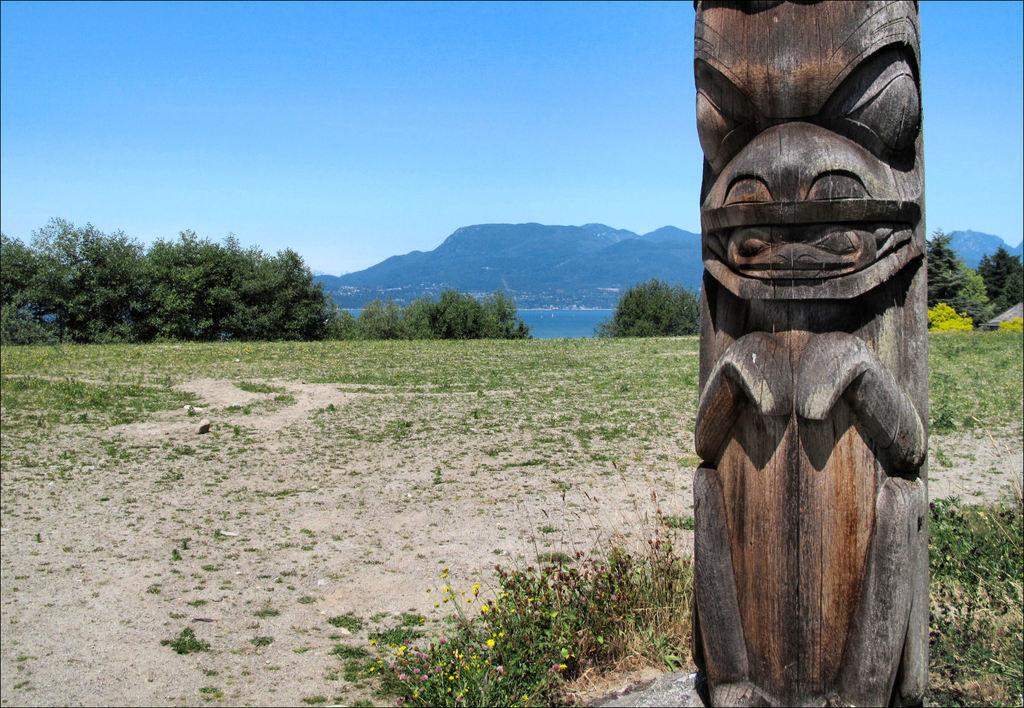What type of structure is visible in the image? There is a wooden structure in the image. What is located behind the wooden structure? There is grass behind the wooden structure. What can be seen in the background of the image? There are trees, a river, mountains, and the sky visible in the background of the image. What type of power is being generated by the wooden structure in the image? There is no indication in the image that the wooden structure is generating any power. Can you see any thread being used in the image? There is no thread visible in the image. 